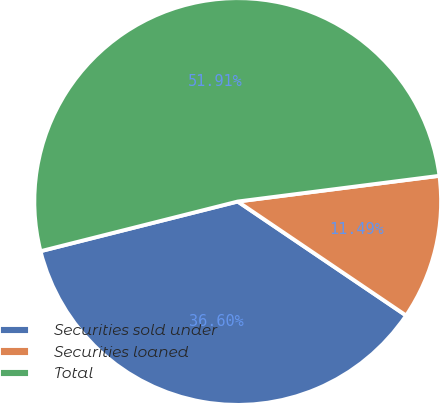<chart> <loc_0><loc_0><loc_500><loc_500><pie_chart><fcel>Securities sold under<fcel>Securities loaned<fcel>Total<nl><fcel>36.6%<fcel>11.49%<fcel>51.91%<nl></chart> 